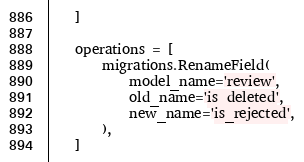<code> <loc_0><loc_0><loc_500><loc_500><_Python_>    ]

    operations = [
        migrations.RenameField(
            model_name='review',
            old_name='is_deleted',
            new_name='is_rejected',
        ),
    ]
</code> 